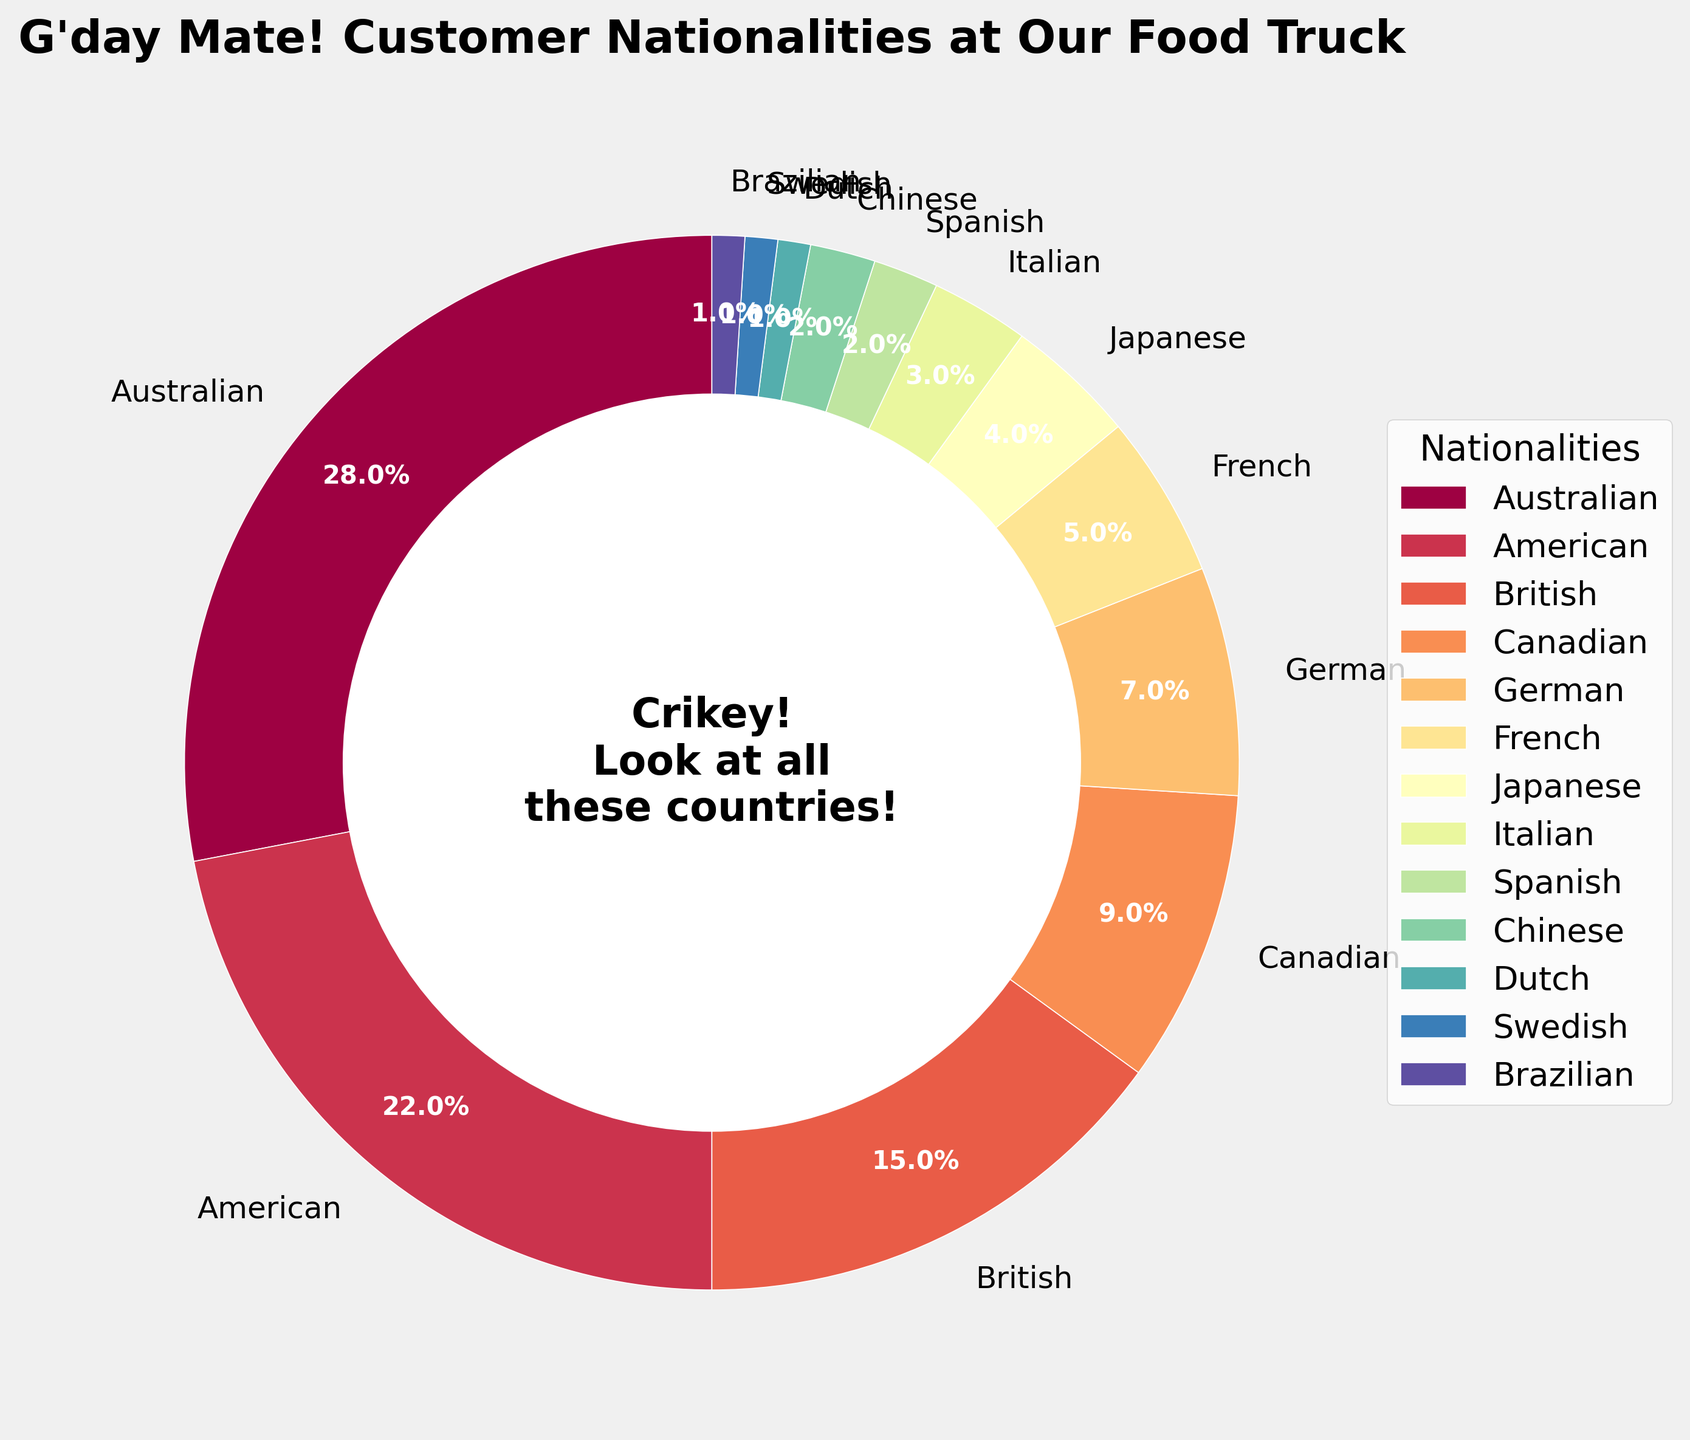what percentage of the food truck customers are from America and Canada together? Look at the percentages for American (22%) and Canadian (9%) customers. Add these two percentages together: 22% + 9% = 31%
Answer: 31% are there more Australian customers or British customers? Compare the percentages of Australian (28%) and British (15%) customers. 28% is greater than 15%, so there are more Australian customers.
Answer: Australian which nationality has the smallest percentage of customers? Identify the nationality with the lowest percentage from the chart. The Dutch, Swedish, and Brazilian nationalities all have the smallest percentage, which is 1%.
Answer: Dutch, Swedish, Brazilian how much more percentage do Australian customers constitute than German customers? Look at the percentages for Australian (28%) and German (7%) customers. Subtract the percentage of German customers from the percentage of Australian customers: 28% - 7% = 21%
Answer: 21% what is the total percentage of European customers? Add the percentages of all European nationalities: British (15%), German (7%), French (5%), Italian (3%), Spanish (2%), Dutch (1%), and Swedish (1%). 15% + 7% + 5% + 3% + 2% + 1% + 1% = 34%
Answer: 34% how does the percentage of Japanese customers compare to the percentage of Spanish customers? Compare the percentages of Japanese (4%) and Spanish (2%) customers. 4% is greater than 2%, so the percentage of Japanese customers is higher.
Answer: Japanese customers constitute a higher percentage what is the combined percentage of the nationalities with less than 5% of the customers each? Add the percentages of the nationalities with less than 5%: Japanese (4%), Italian (3%), Spanish (2%), Chinese (2%), Dutch (1%), Swedish (1%), and Brazilian (1%). 4% + 3% + 2% + 2% + 1% + 1% + 1% = 14%
Answer: 14% how many times greater is the percentage of Australian customers than that of Chinese customers? Look at the percentages for Australian (28%) and Chinese (2%) customers. Divide the percentage of Australian customers by the percentage of Chinese customers: 28% / 2% = 14
Answer: 14 times which nationality has a customer percentage closest to 10%? Identify the nationality whose percentage is closest to 10%. Canadian customers constitute 9%, which is the closest to 10%.
Answer: Canadian how many nationalities have a customer percentage greater than 5%? Count the nationalities with percentages greater than 5%: Australian (28%), American (22%), British (15%), Canadian (9%), and German (7%). There are 5 nationalities with more than 5%.
Answer: 5 